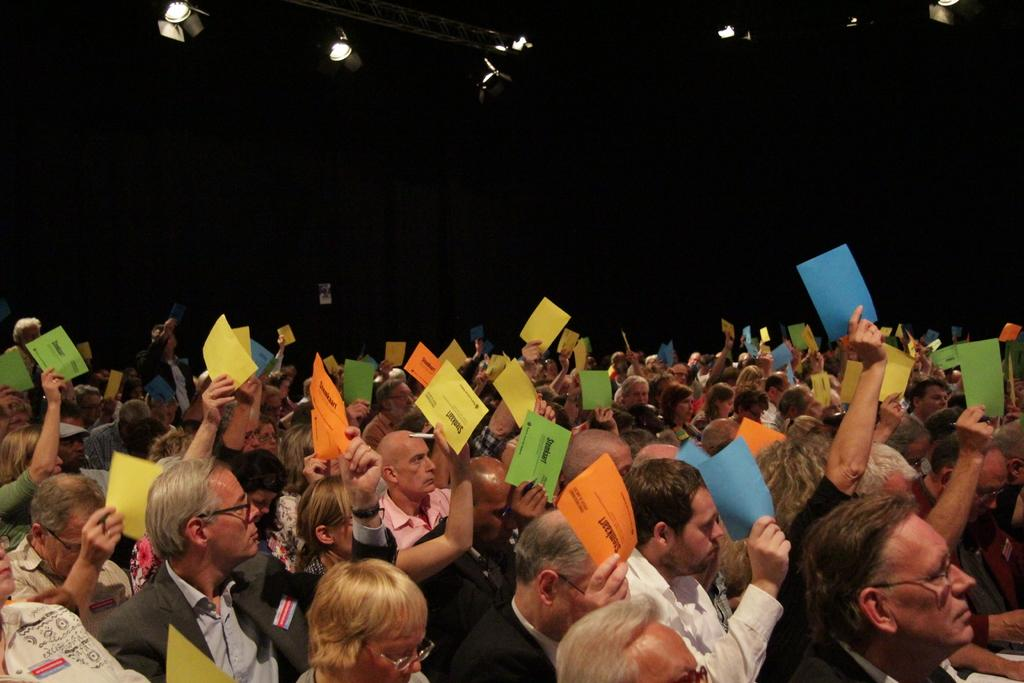What are the people in the image doing? The people in the image are sitting and holding papers in their hands. What can be seen on the ceiling in the image? There are lights on the ceiling in the image. How would you describe the lighting in the image? The background of the image is dark, which suggests that the lighting is dim or low. What type of apparatus is being used to improve the acoustics in the room? There is no apparatus mentioned or visible in the image that is related to improving acoustics. 